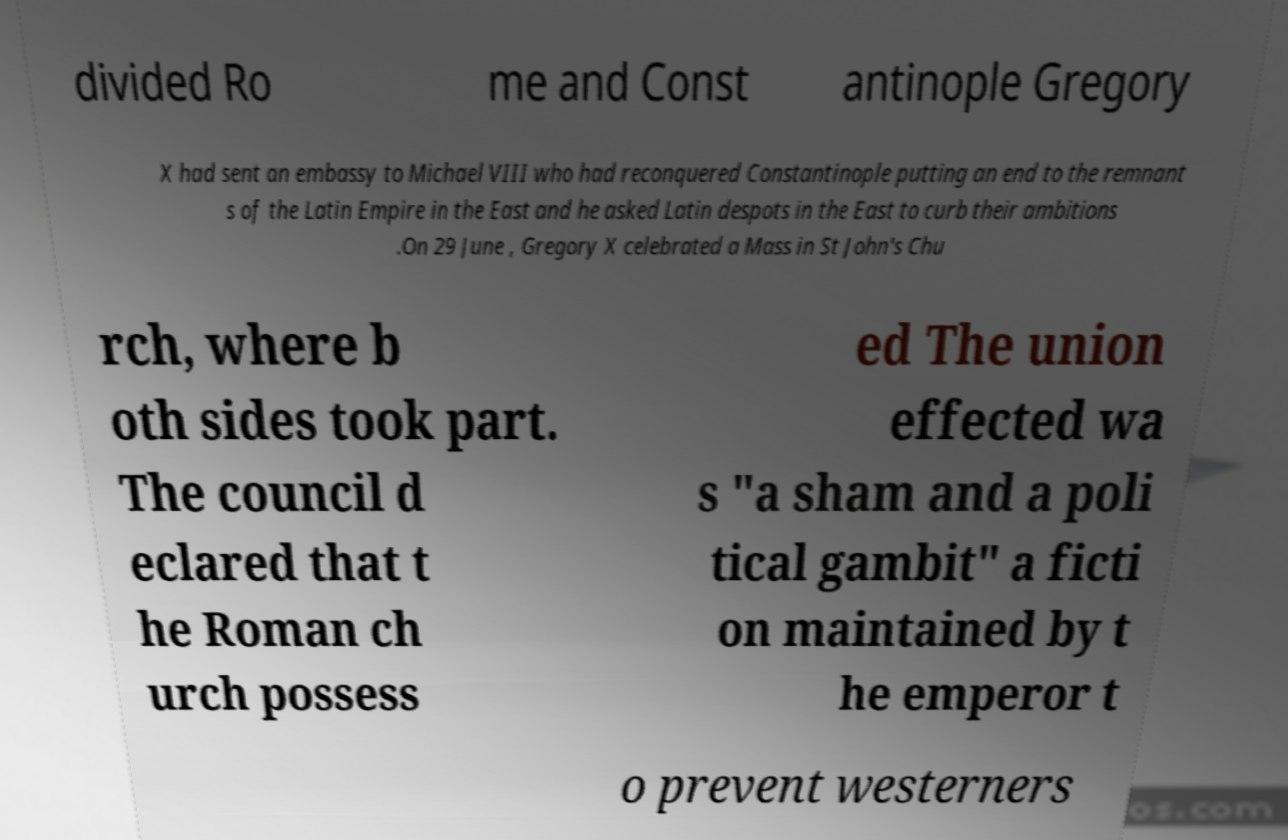I need the written content from this picture converted into text. Can you do that? divided Ro me and Const antinople Gregory X had sent an embassy to Michael VIII who had reconquered Constantinople putting an end to the remnant s of the Latin Empire in the East and he asked Latin despots in the East to curb their ambitions .On 29 June , Gregory X celebrated a Mass in St John's Chu rch, where b oth sides took part. The council d eclared that t he Roman ch urch possess ed The union effected wa s "a sham and a poli tical gambit" a ficti on maintained by t he emperor t o prevent westerners 